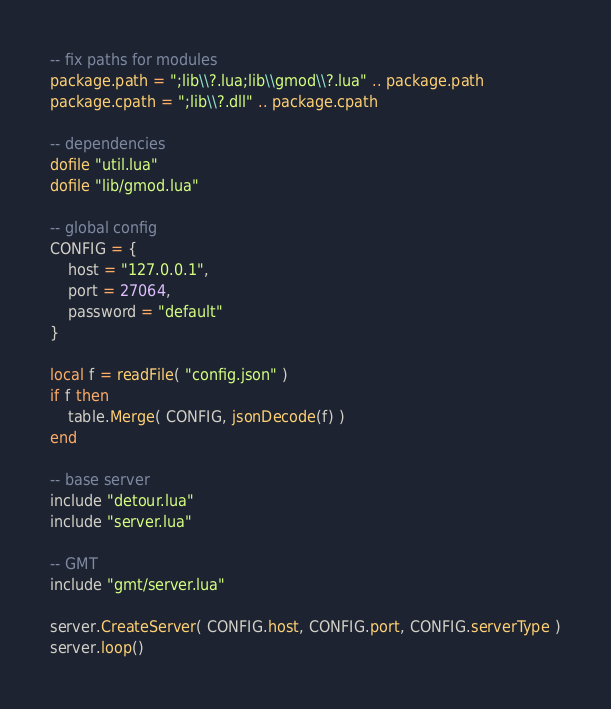<code> <loc_0><loc_0><loc_500><loc_500><_Lua_>-- fix paths for modules
package.path = ";lib\\?.lua;lib\\gmod\\?.lua" .. package.path
package.cpath = ";lib\\?.dll" .. package.cpath

-- dependencies
dofile "util.lua"
dofile "lib/gmod.lua"

-- global config
CONFIG = {
	host = "127.0.0.1",
	port = 27064,
	password = "default"
}

local f = readFile( "config.json" )
if f then
	table.Merge( CONFIG, jsonDecode(f) )
end

-- base server
include "detour.lua"
include "server.lua"

-- GMT
include "gmt/server.lua"

server.CreateServer( CONFIG.host, CONFIG.port, CONFIG.serverType )
server.loop()
</code> 